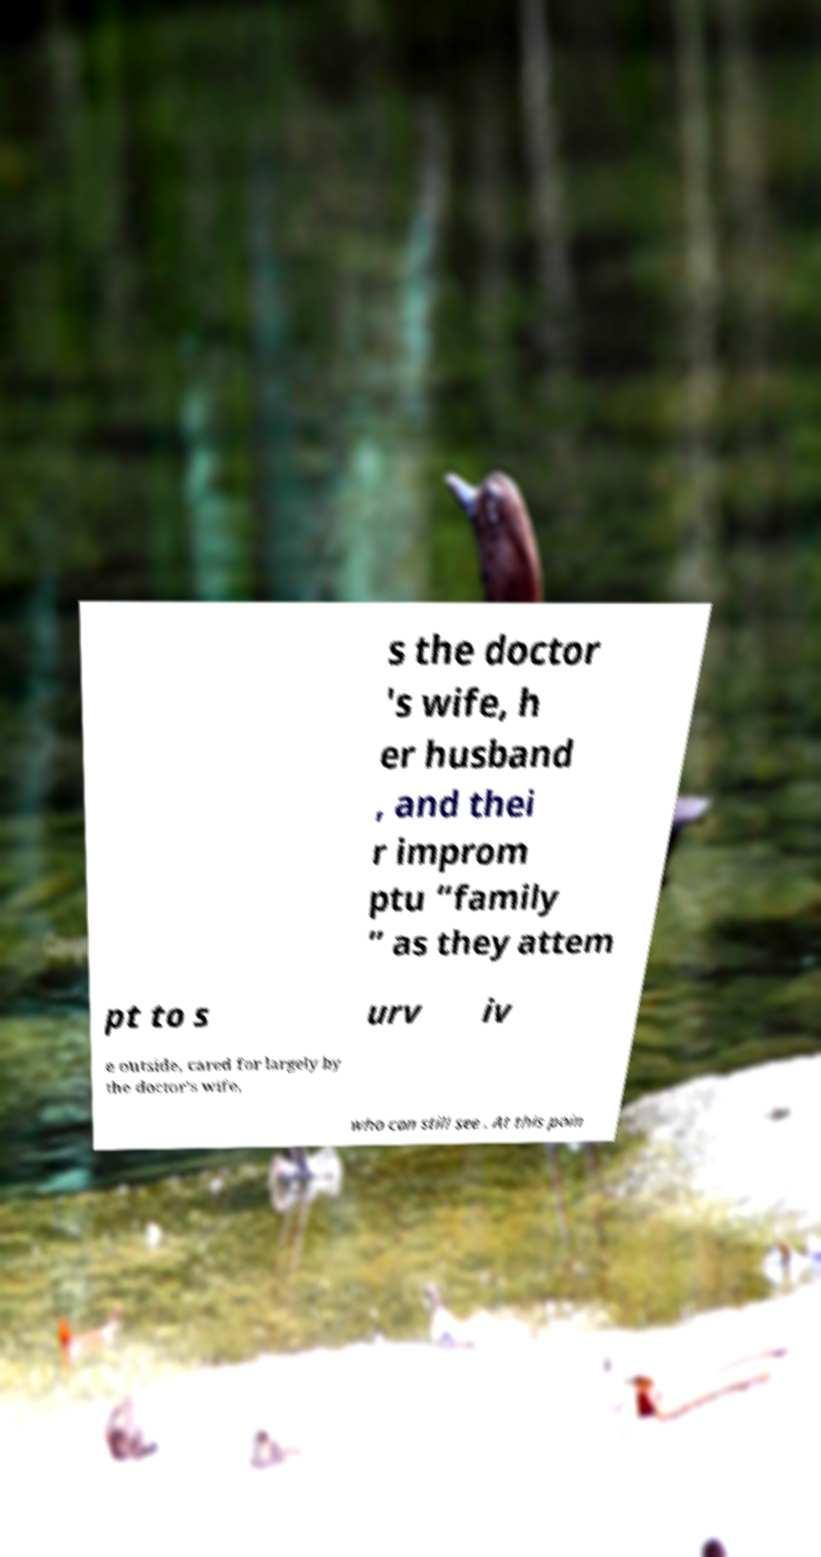Can you read and provide the text displayed in the image?This photo seems to have some interesting text. Can you extract and type it out for me? s the doctor 's wife, h er husband , and thei r improm ptu “family ” as they attem pt to s urv iv e outside, cared for largely by the doctor’s wife, who can still see . At this poin 